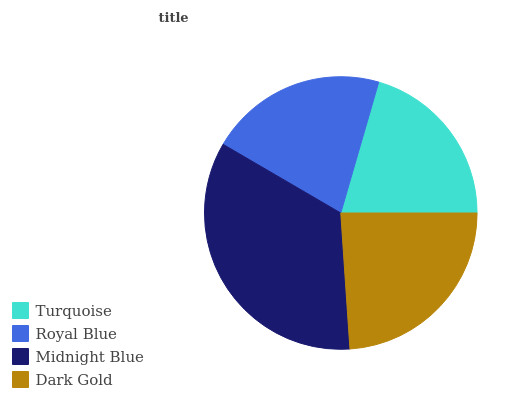Is Turquoise the minimum?
Answer yes or no. Yes. Is Midnight Blue the maximum?
Answer yes or no. Yes. Is Royal Blue the minimum?
Answer yes or no. No. Is Royal Blue the maximum?
Answer yes or no. No. Is Royal Blue greater than Turquoise?
Answer yes or no. Yes. Is Turquoise less than Royal Blue?
Answer yes or no. Yes. Is Turquoise greater than Royal Blue?
Answer yes or no. No. Is Royal Blue less than Turquoise?
Answer yes or no. No. Is Dark Gold the high median?
Answer yes or no. Yes. Is Royal Blue the low median?
Answer yes or no. Yes. Is Turquoise the high median?
Answer yes or no. No. Is Midnight Blue the low median?
Answer yes or no. No. 